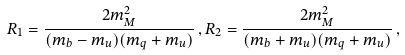<formula> <loc_0><loc_0><loc_500><loc_500>R _ { 1 } = \frac { 2 m _ { M } ^ { 2 } } { ( m _ { b } - m _ { u } ) ( m _ { q } + m _ { u } ) } \, , R _ { 2 } = \frac { 2 m _ { M } ^ { 2 } } { ( m _ { b } + m _ { u } ) ( m _ { q } + m _ { u } ) } \, ,</formula> 